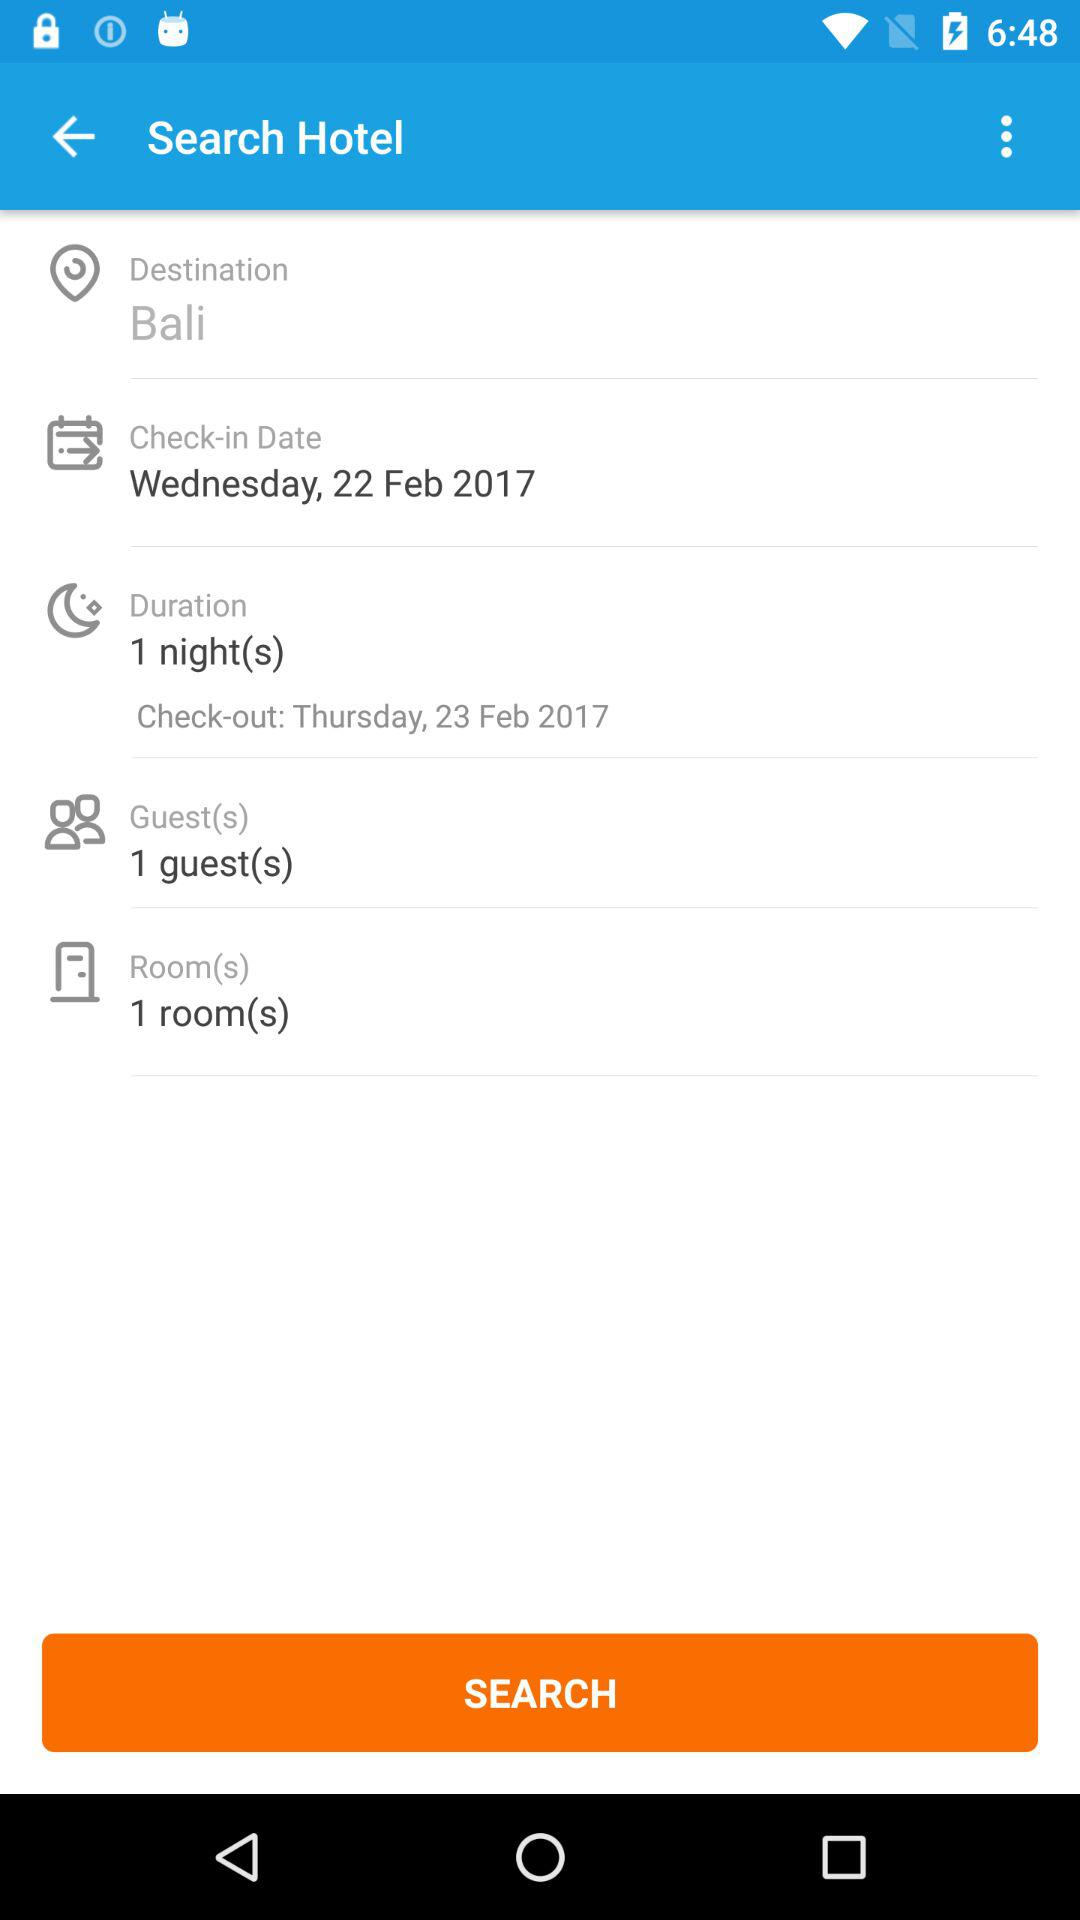How many days are there between the check-in and check-out dates?
Answer the question using a single word or phrase. 1 